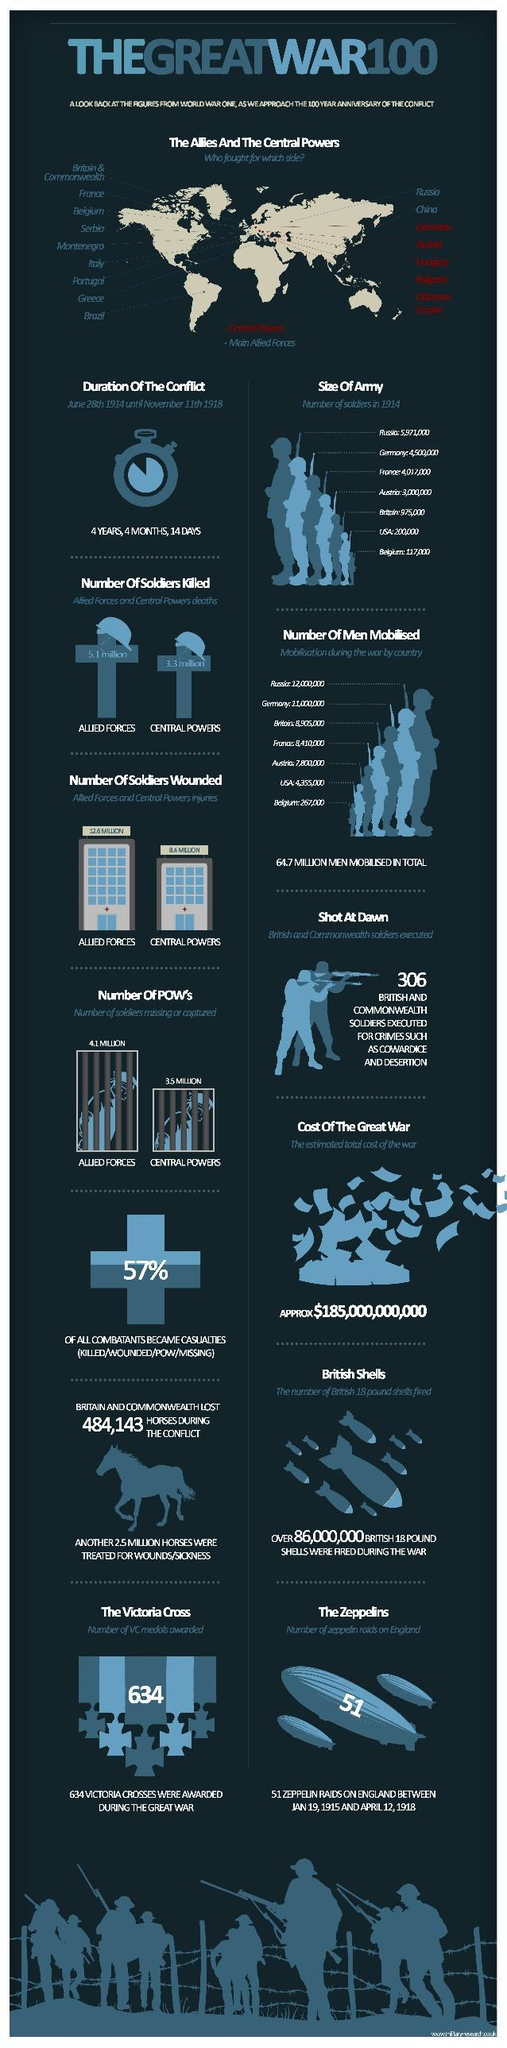How many were taken as prisoners of war (POW) from the Central powers?
Answer the question with a short phrase. 3.5 million How many soldiers from the Allied forces were wounded? 12.6 million On whose side was France and Italy? The Allies How many soldiers were lost by the Central powers? 3.3 million How many soldiers were totally wounded in the war ( million)? 21 What was the cost of the great war? $185,000,000,000 How many soldiers from the central powers were wounded? 8.4 million How many British shells were fired? 86,000,000 What was the duration of the conflict? 4 years, 4 months, 14 days How many men were mobilized from Germany? 11,000,000 How many VC medals were given during the war? 634 Which country had the highest number of soldiers in 1914? Russia How many men were mobilized in the USA? 4,355,000 What was the total number of POWs in the war(million)? 7.6 How many soldiers in the allied forces were killed? 5.1 million How many countries sided with the central powers? 6 Totally how many horses were lost, wounded or sick due to the war? 25,484,143 What was the number of POWs from the Allies? 4.1 million Which were the eastern countries that sided with the Allies? Russia, China How many were 'shot at dawn'? 306 What percentage of the combatants became casualties? 57% Which country siding with the Central powers had the biggest army? Germany Who had more soldiers - France, Germany or Belgium? Germany Against whom were the Allies warring? The Central powers 